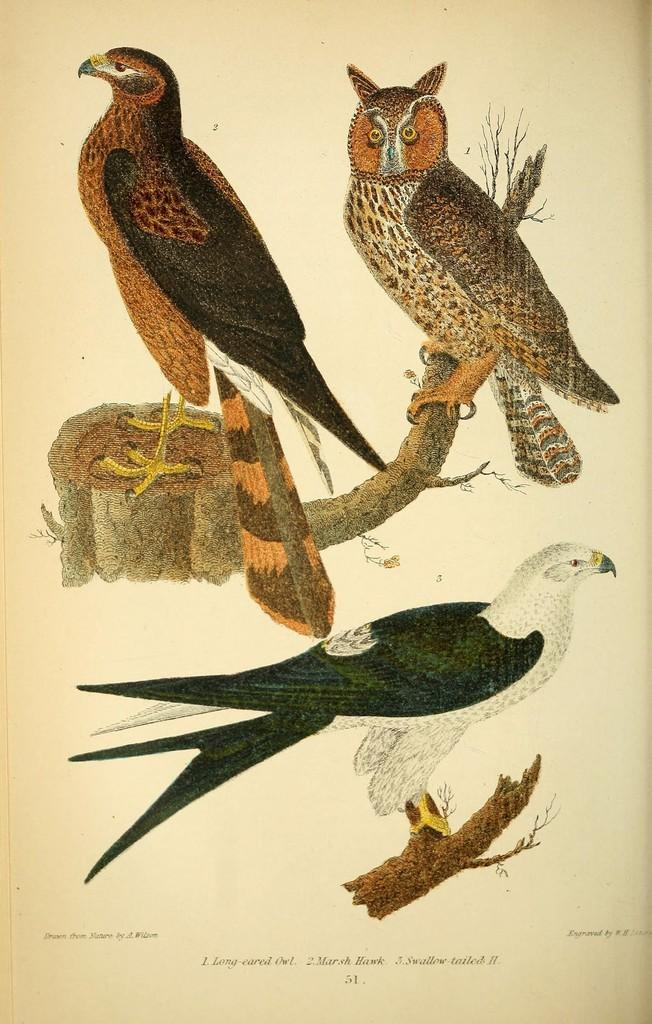What type of animals are depicted in the pictures in the image? There are pictures of birds in the image. What else can be found at the bottom of the image? There is text at the bottom of the image. What type of underwear is being advertised in the image? There is no underwear present in the image; it features pictures of birds and text. What cause is being promoted in the image? The image does not promote any specific cause; it only contains pictures of birds and text. 